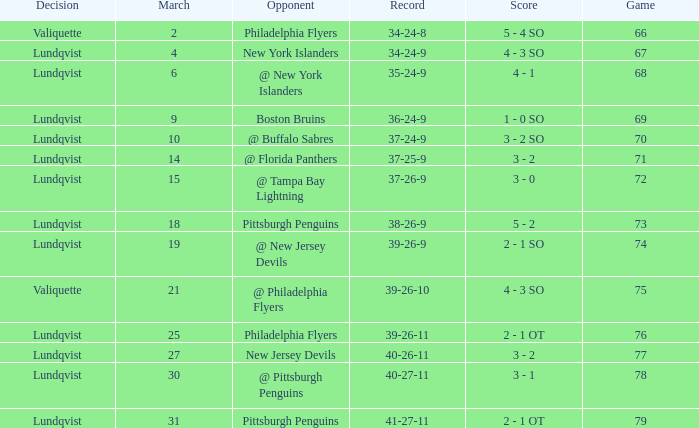Which opponent's game was less than 76 when the march was 10? @ Buffalo Sabres. 